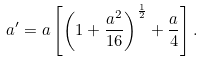Convert formula to latex. <formula><loc_0><loc_0><loc_500><loc_500>a ^ { \prime } = a \left [ \left ( 1 + \frac { a ^ { 2 } } { 1 6 } \right ) ^ { \frac { 1 } { 2 } } + \frac { a } { 4 } \right ] .</formula> 